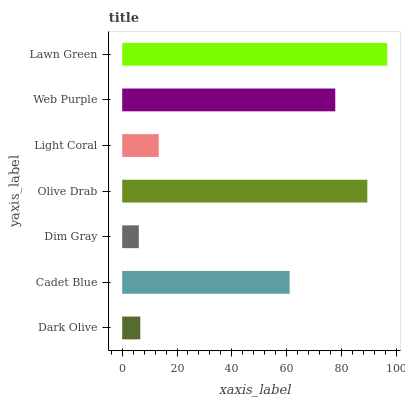Is Dim Gray the minimum?
Answer yes or no. Yes. Is Lawn Green the maximum?
Answer yes or no. Yes. Is Cadet Blue the minimum?
Answer yes or no. No. Is Cadet Blue the maximum?
Answer yes or no. No. Is Cadet Blue greater than Dark Olive?
Answer yes or no. Yes. Is Dark Olive less than Cadet Blue?
Answer yes or no. Yes. Is Dark Olive greater than Cadet Blue?
Answer yes or no. No. Is Cadet Blue less than Dark Olive?
Answer yes or no. No. Is Cadet Blue the high median?
Answer yes or no. Yes. Is Cadet Blue the low median?
Answer yes or no. Yes. Is Lawn Green the high median?
Answer yes or no. No. Is Olive Drab the low median?
Answer yes or no. No. 